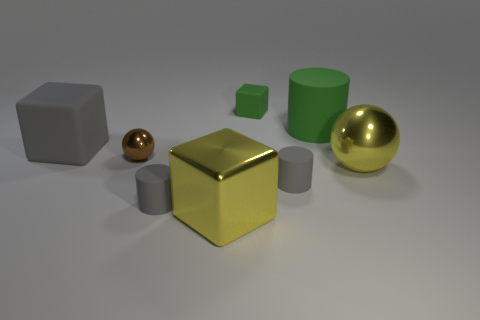Is there a tiny gray rubber cylinder?
Your answer should be very brief. Yes. What number of things are objects in front of the big cylinder or large yellow metal objects in front of the large shiny sphere?
Your response must be concise. 6. Does the small rubber block have the same color as the metal cube?
Your answer should be very brief. No. Is the number of yellow metal cubes less than the number of metal cylinders?
Your answer should be compact. No. Are there any green cubes on the right side of the gray cube?
Give a very brief answer. Yes. Does the small block have the same material as the yellow ball?
Provide a short and direct response. No. What is the color of the large metal thing that is the same shape as the tiny green matte object?
Offer a very short reply. Yellow. Is the color of the cylinder left of the tiny green cube the same as the large rubber cube?
Your answer should be very brief. Yes. The big shiny object that is the same color as the large shiny sphere is what shape?
Ensure brevity in your answer.  Cube. What number of gray objects have the same material as the green cylinder?
Make the answer very short. 3. 